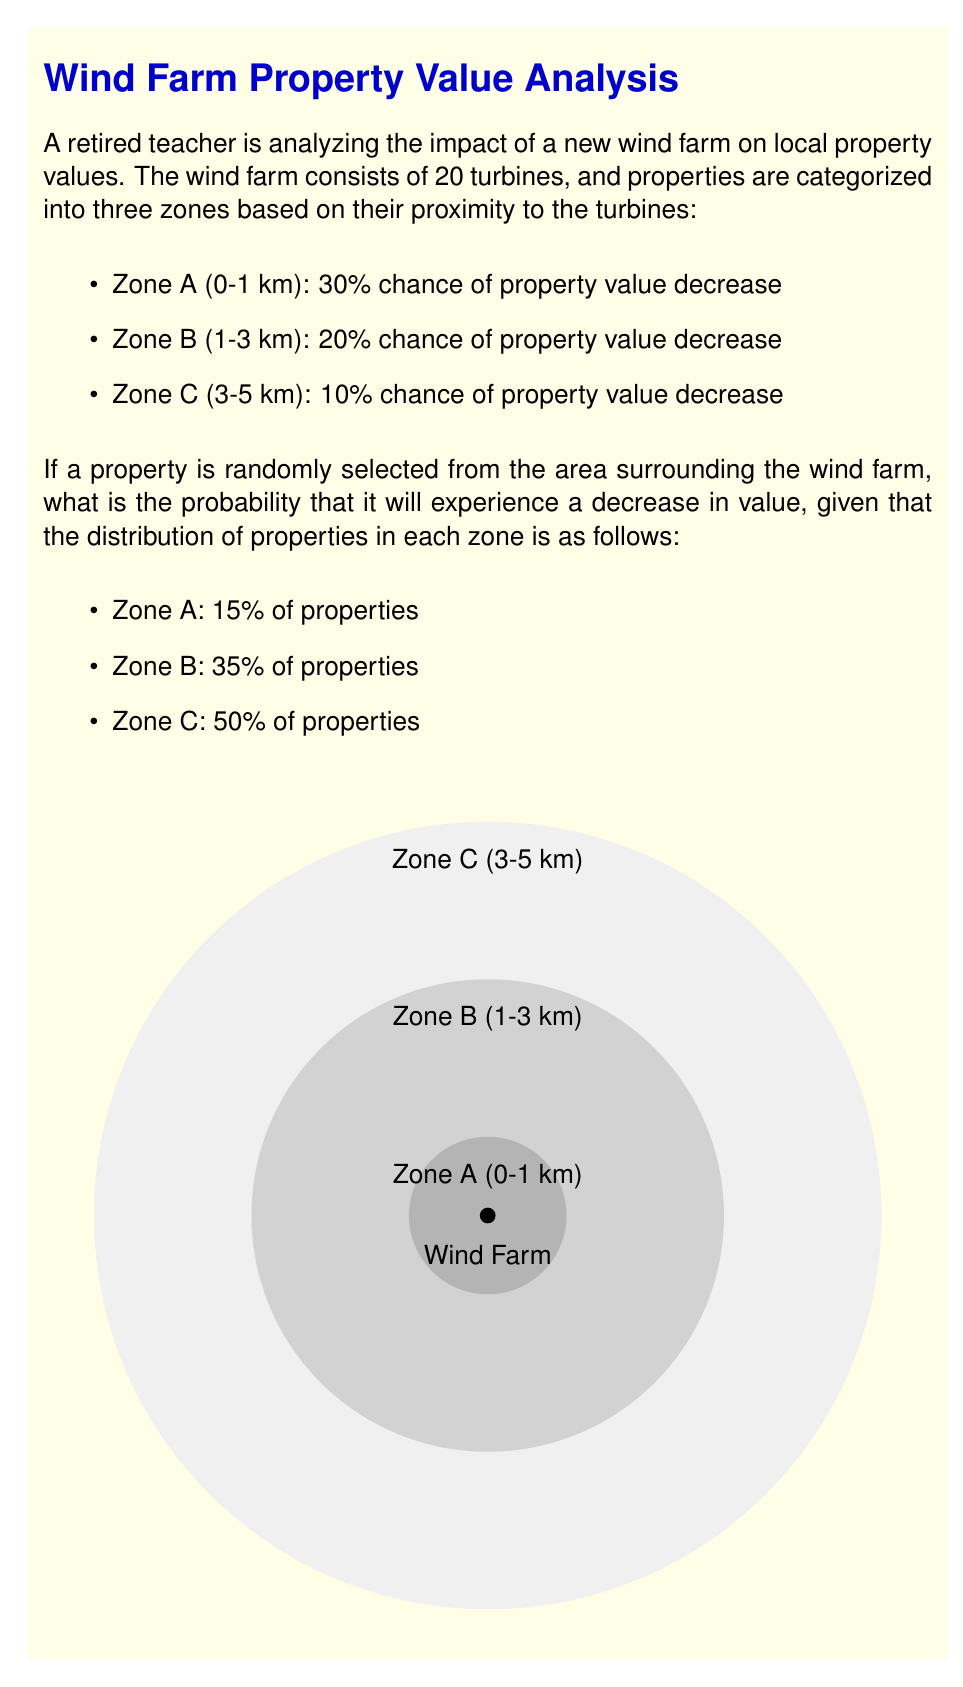Provide a solution to this math problem. To solve this problem, we'll use the law of total probability. Let's break it down step-by-step:

1) Let D be the event that a property experiences a decrease in value.
   Let A, B, and C represent the events that a property is in Zone A, B, or C respectively.

2) We need to calculate:
   $$P(D) = P(D|A)P(A) + P(D|B)P(B) + P(D|C)P(C)$$

3) We're given:
   $P(D|A) = 0.30$, $P(D|B) = 0.20$, $P(D|C) = 0.10$
   $P(A) = 0.15$, $P(B) = 0.35$, $P(C) = 0.50$

4) Let's substitute these values:
   $$P(D) = (0.30)(0.15) + (0.20)(0.35) + (0.10)(0.50)$$

5) Now, let's calculate each term:
   $$(0.30)(0.15) = 0.045$$
   $$(0.20)(0.35) = 0.070$$
   $$(0.10)(0.50) = 0.050$$

6) Sum up the terms:
   $$P(D) = 0.045 + 0.070 + 0.050 = 0.165$$

Therefore, the probability that a randomly selected property will experience a decrease in value is 0.165 or 16.5%.
Answer: $0.165$ or $16.5\%$ 